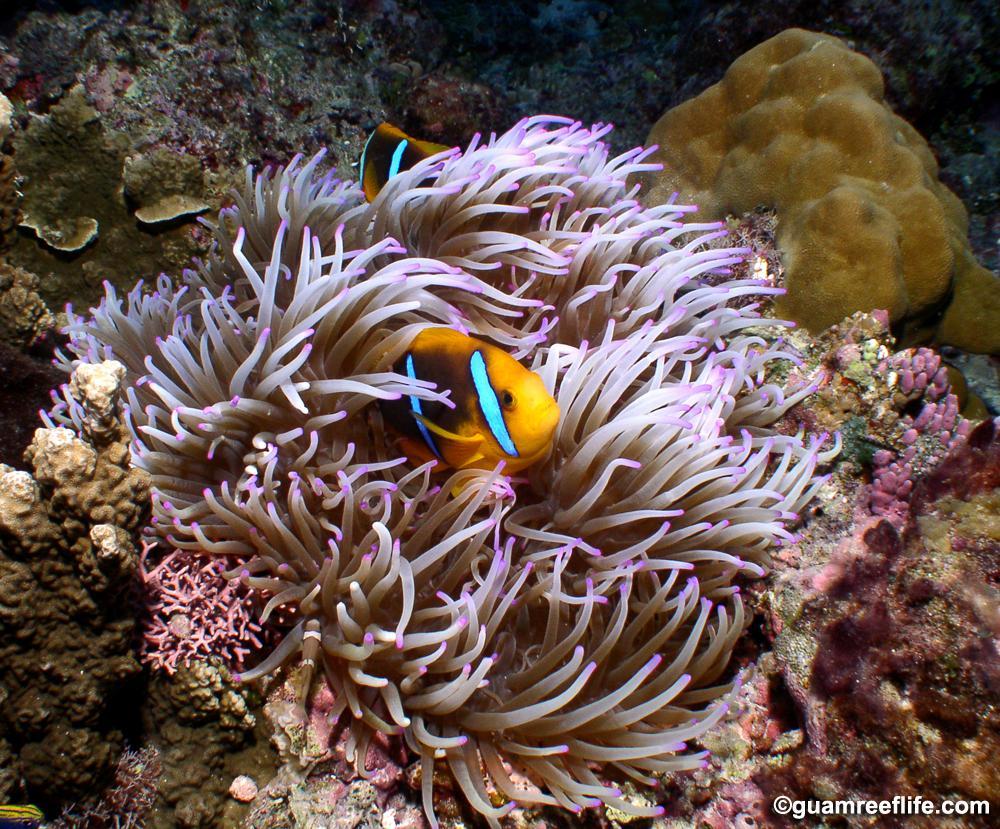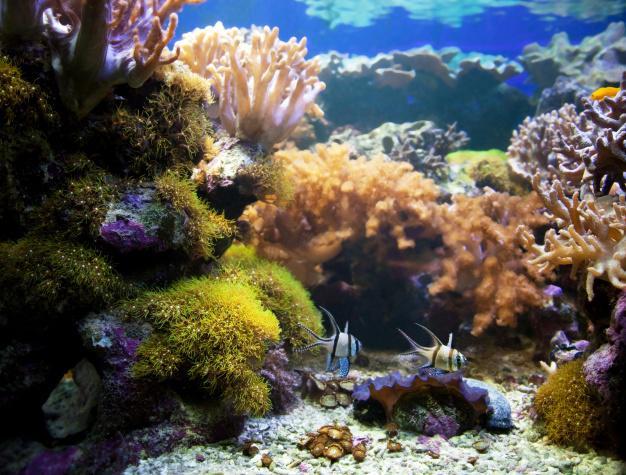The first image is the image on the left, the second image is the image on the right. Considering the images on both sides, is "There are clown fish in the left image." valid? Answer yes or no. Yes. The first image is the image on the left, the second image is the image on the right. Evaluate the accuracy of this statement regarding the images: "At least one colorful fish is near the purple-tipped slender tendrils of an anemone in one image.". Is it true? Answer yes or no. Yes. 